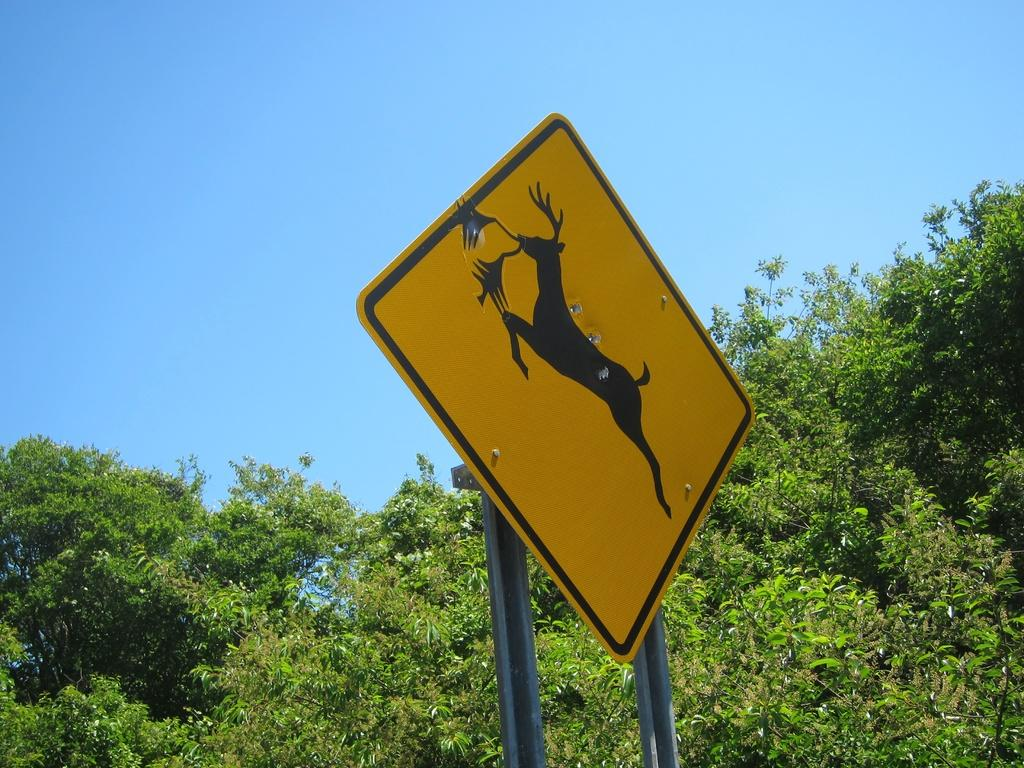What can be seen in the background of the image? There is sky visible in the image. What type of natural elements are present in the image? There are trees in the image. What object can be seen in the foreground of the image? There is a board in the image. What songs can be heard playing in the background of the image? There is no audio or indication of songs in the image; it only contains visual elements. 